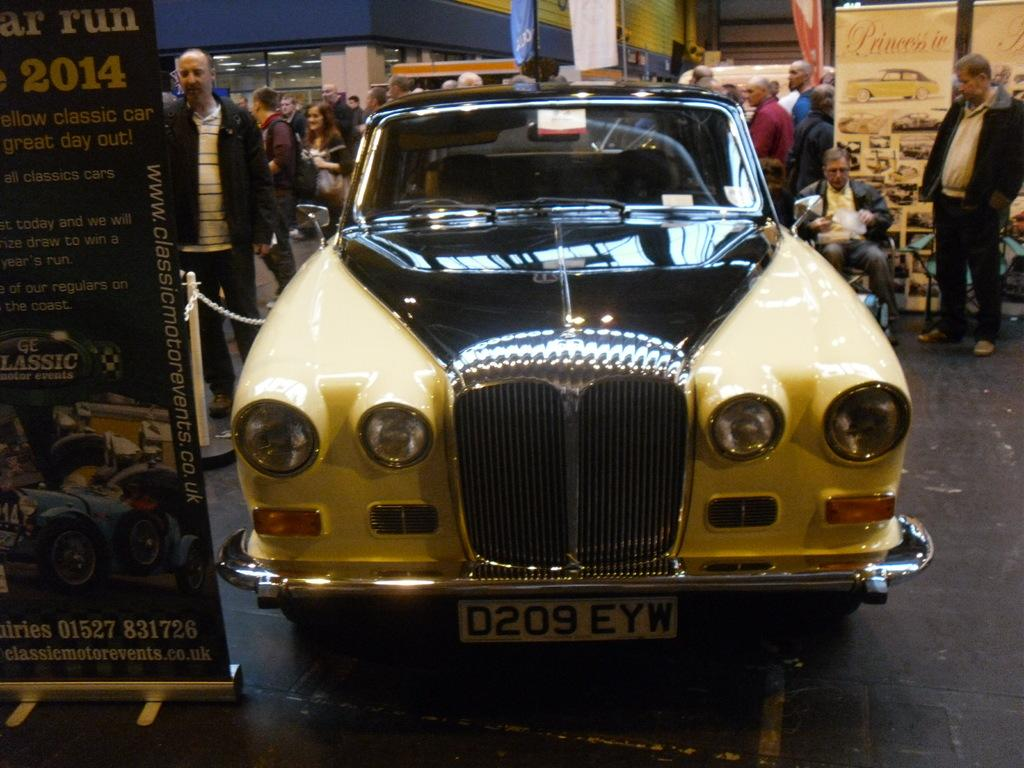Provide a one-sentence caption for the provided image. Older car with a model license plate that says D209 EYW. 